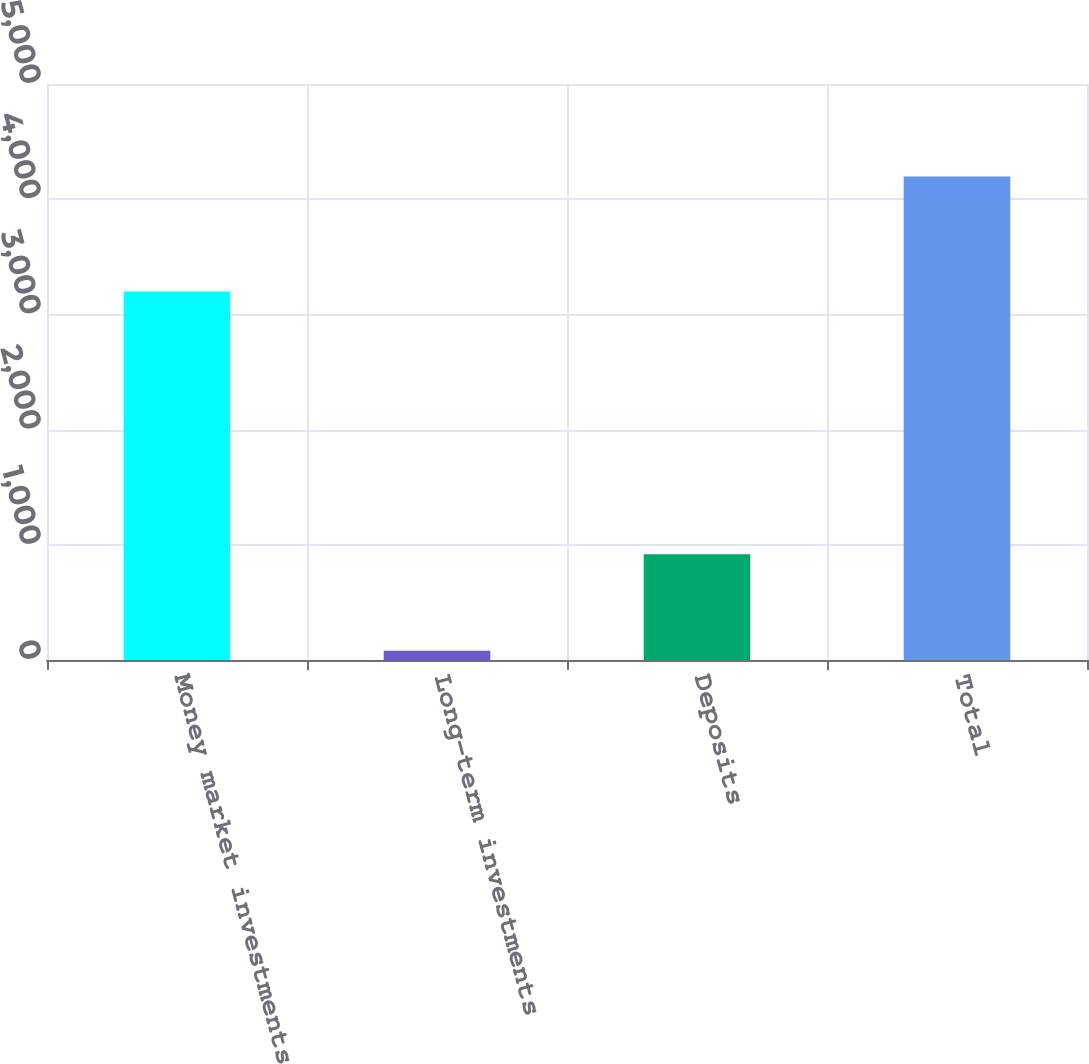Convert chart to OTSL. <chart><loc_0><loc_0><loc_500><loc_500><bar_chart><fcel>Money market investments<fcel>Long-term investments<fcel>Deposits<fcel>Total<nl><fcel>3199<fcel>80<fcel>917<fcel>4196<nl></chart> 